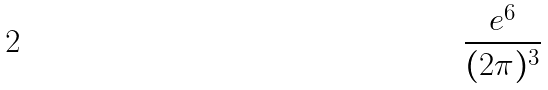Convert formula to latex. <formula><loc_0><loc_0><loc_500><loc_500>\frac { e ^ { 6 } } { ( 2 \pi ) ^ { 3 } }</formula> 